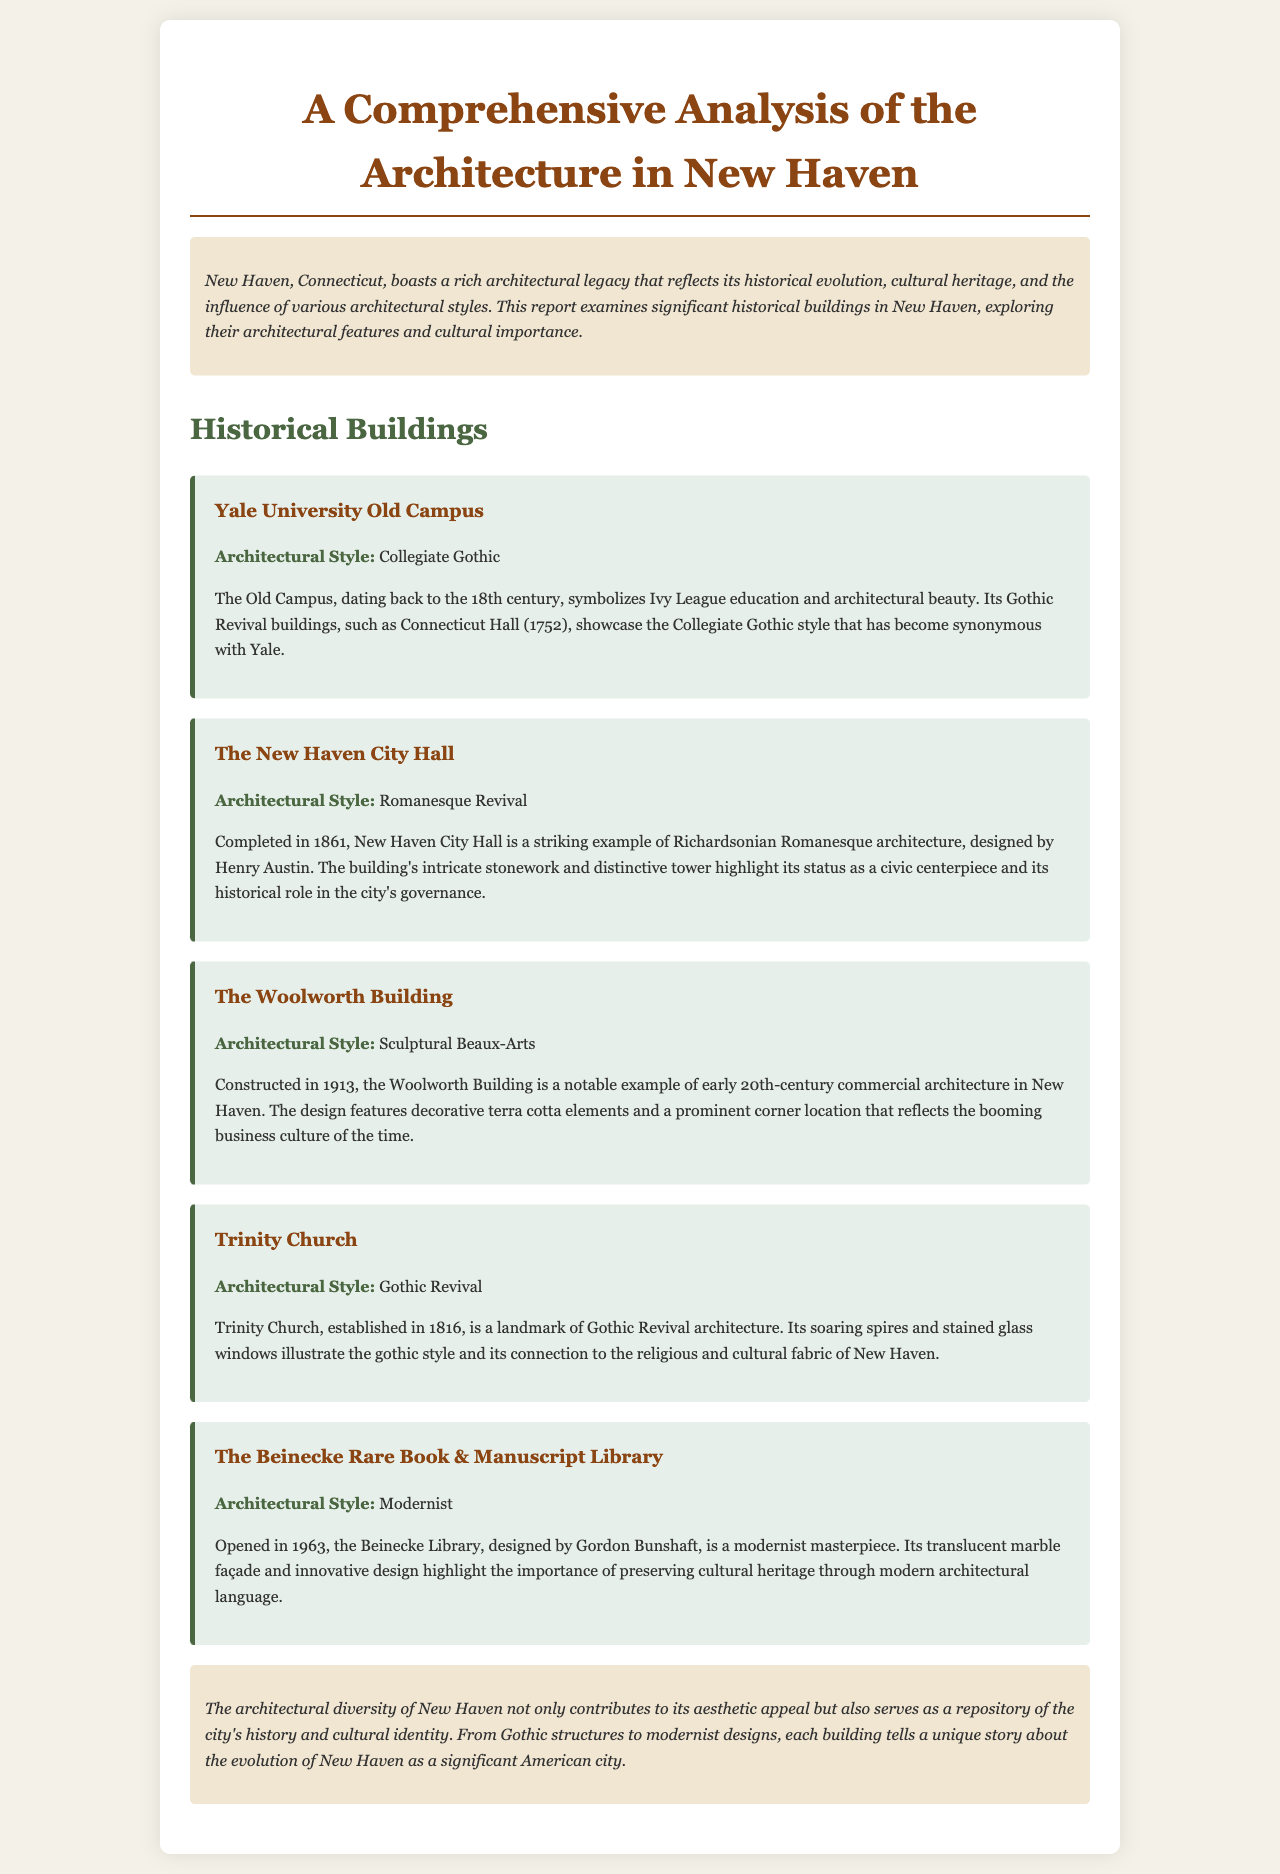what architectural style is the Yale University Old Campus? The document states that the architectural style of the Yale University Old Campus is Collegiate Gothic.
Answer: Collegiate Gothic when was the New Haven City Hall completed? The report mentions that New Haven City Hall was completed in 1861.
Answer: 1861 who designed the Beinecke Rare Book & Manuscript Library? According to the document, the Beinecke Library was designed by Gordon Bunshaft.
Answer: Gordon Bunshaft what is the significance of Trinity Church? The document describes Trinity Church as a landmark of Gothic Revival architecture, illustrating its connection to the religious and cultural fabric of New Haven.
Answer: Landmark of Gothic Revival architecture how many historical buildings are presented in the report? The report discusses five historical buildings in New Haven.
Answer: Five what year was the Woolworth Building constructed? The document states that the Woolworth Building was constructed in 1913.
Answer: 1913 which architectural style is represented by New Haven City Hall? The report identifies New Haven City Hall's architectural style as Romanesque Revival.
Answer: Romanesque Revival what is the architectural style of the Beinecke Library? The document indicates that the Beinecke Library's architectural style is Modernist.
Answer: Modernist 